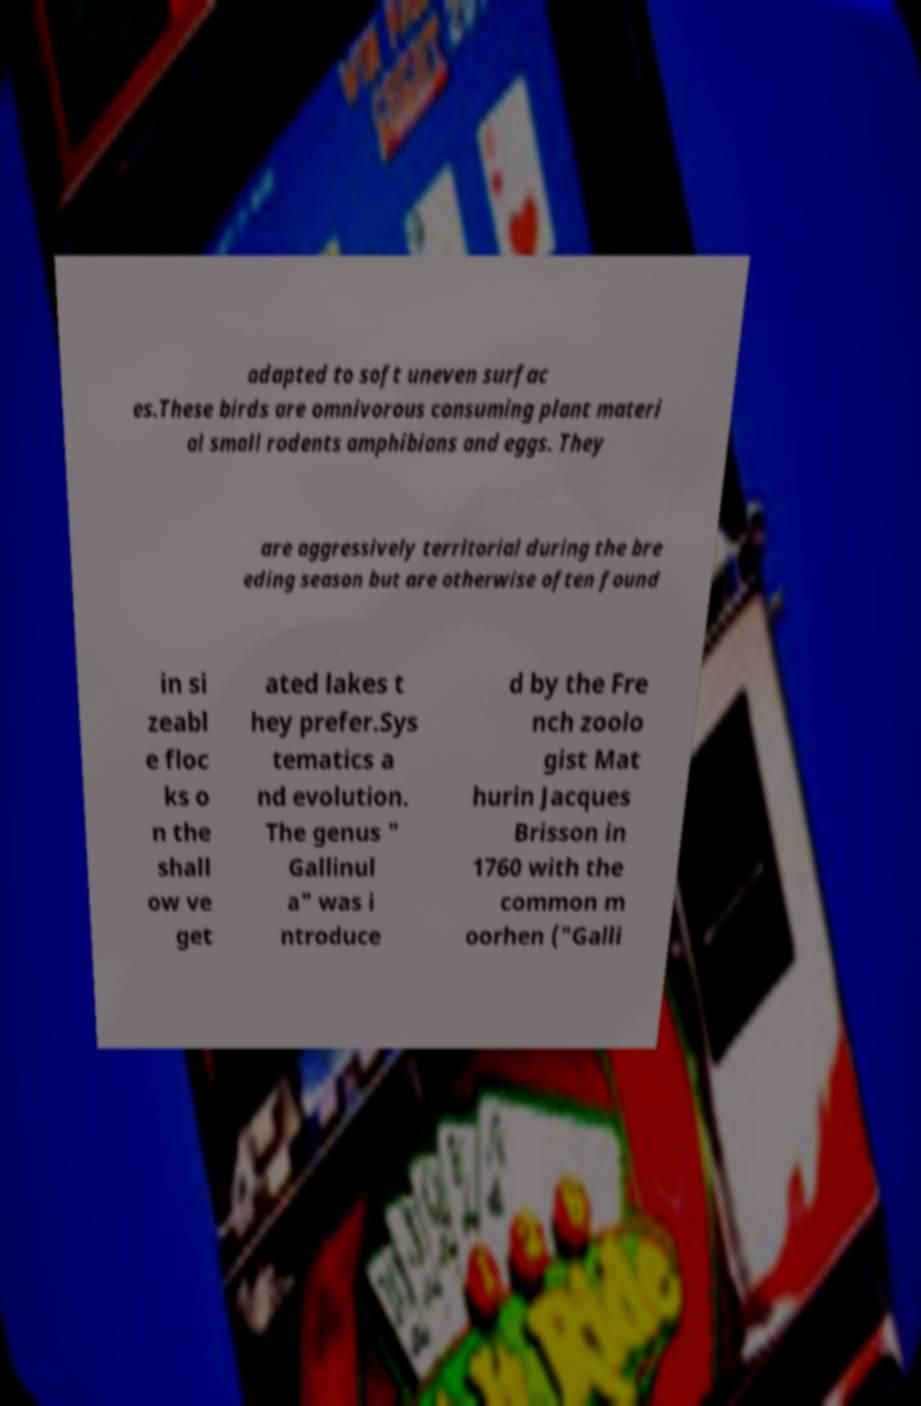For documentation purposes, I need the text within this image transcribed. Could you provide that? adapted to soft uneven surfac es.These birds are omnivorous consuming plant materi al small rodents amphibians and eggs. They are aggressively territorial during the bre eding season but are otherwise often found in si zeabl e floc ks o n the shall ow ve get ated lakes t hey prefer.Sys tematics a nd evolution. The genus " Gallinul a" was i ntroduce d by the Fre nch zoolo gist Mat hurin Jacques Brisson in 1760 with the common m oorhen ("Galli 